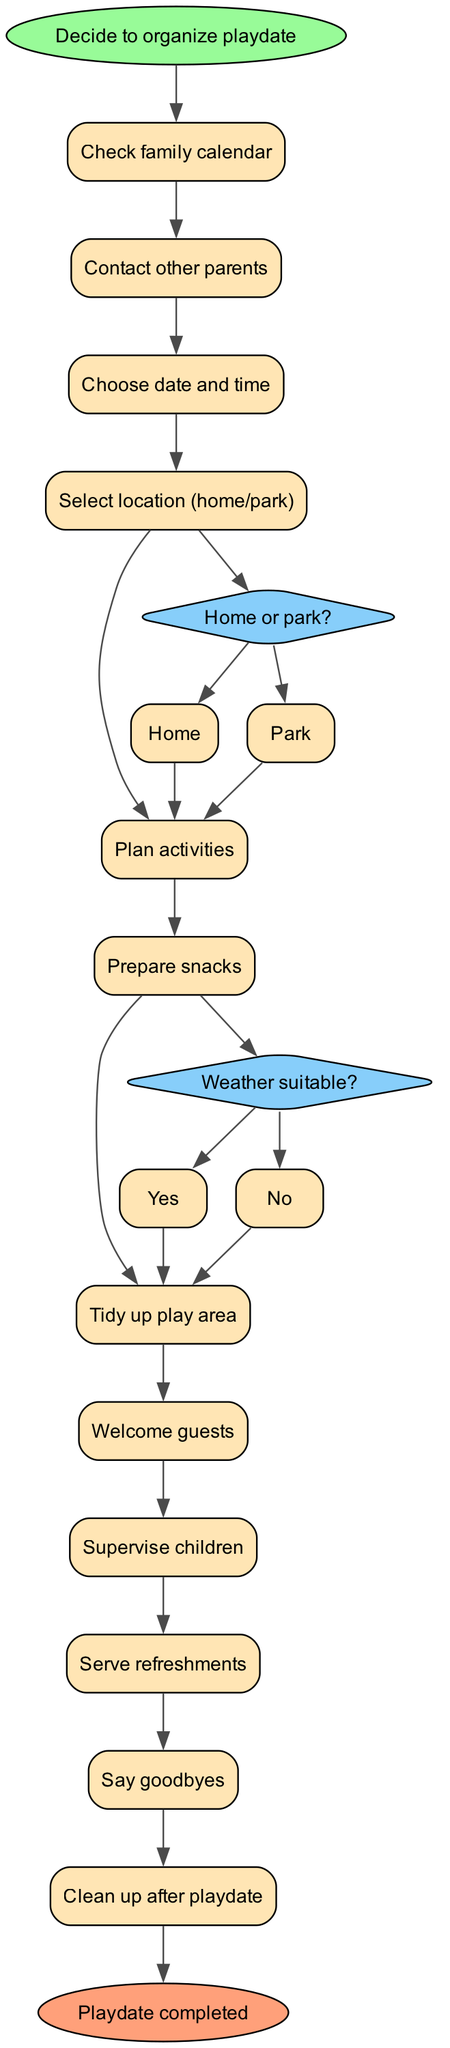What is the starting point of the playdate organization process? The starting point is clearly labeled in the diagram as "Decide to organize playdate". This is identified as the first node leading to the subsequent activities.
Answer: Decide to organize playdate How many activities are listed in the diagram? By counting each activity node from the diagram, there are 12 distinct activities leading to the process flow.
Answer: 12 What is the first activity listed after the start? The first activity is specified right after the start node, which is "Check family calendar". It is the immediate next step in the flow.
Answer: Check family calendar What question is posed before selecting a location? The question posed before selecting a location is "Home or park?". This decision node is directly linked to the activity of choosing the location.
Answer: Home or park? What happens if the weather is not suitable? If the weather is not suitable, it leads back to the "Select location (home/park)" option in the decision node, indicating a need to re-evaluate the location choices.
Answer: Select location (home/park) Which activity comes after "Serve refreshments"? The activity following "Serve refreshments" is "Say goodbyes", indicating the next step after refreshments have been served.
Answer: Say goodbyes What color are the decision nodes in the diagram? The decision nodes are colored in light blue, specified by the fillcolor attribute associated with their graphical representation.
Answer: Light blue At which point do guests receive a welcome? Guests receive a welcome after the activity "Tidy up play area", as the "Welcome guests" activity directly follows this preparation step in the flow.
Answer: Welcome guests How many decisions are represented in the diagram? There are 2 decision nodes shown in the diagram, which require choices related to location and weather.
Answer: 2 What marks the end of the playdate process? The end of the playdate process is marked by the node "Playdate completed", which concludes the flow of activities outlined in the diagram.
Answer: Playdate completed 